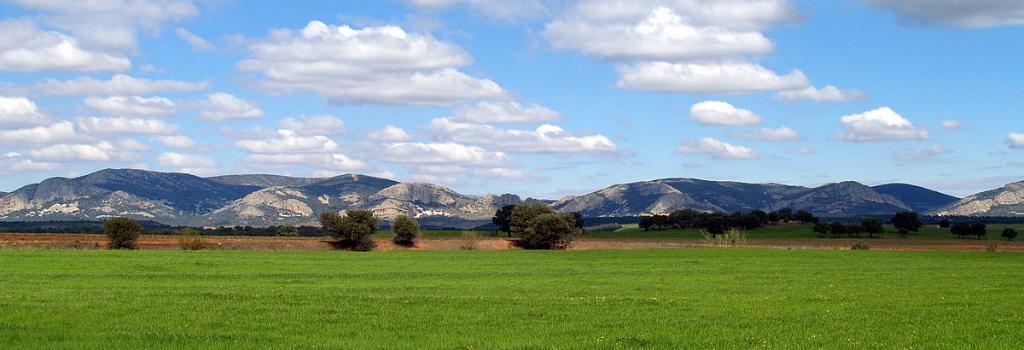Describe this image in one or two sentences. In this image there is a grass fields, tree and mountains, also there are clouds in the sky. 